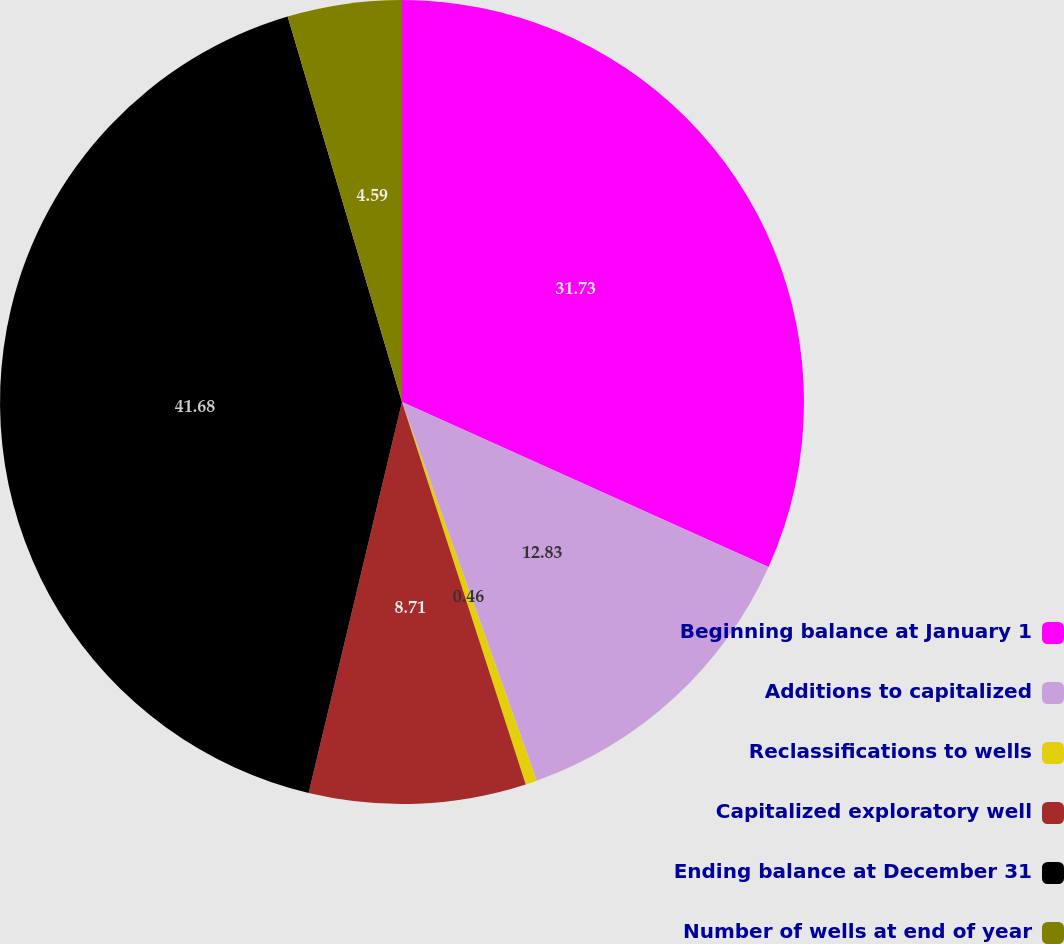Convert chart. <chart><loc_0><loc_0><loc_500><loc_500><pie_chart><fcel>Beginning balance at January 1<fcel>Additions to capitalized<fcel>Reclassifications to wells<fcel>Capitalized exploratory well<fcel>Ending balance at December 31<fcel>Number of wells at end of year<nl><fcel>31.73%<fcel>12.83%<fcel>0.46%<fcel>8.71%<fcel>41.68%<fcel>4.59%<nl></chart> 